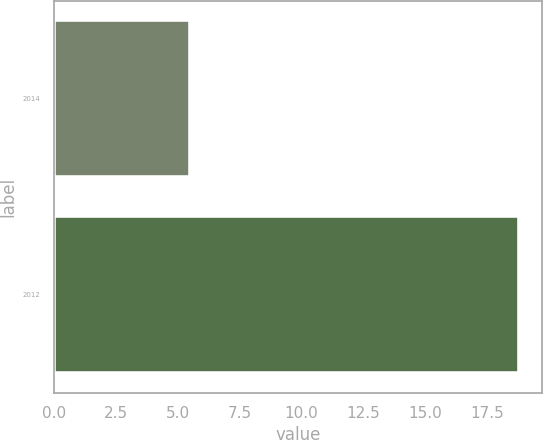Convert chart to OTSL. <chart><loc_0><loc_0><loc_500><loc_500><bar_chart><fcel>2014<fcel>2012<nl><fcel>5.5<fcel>18.8<nl></chart> 